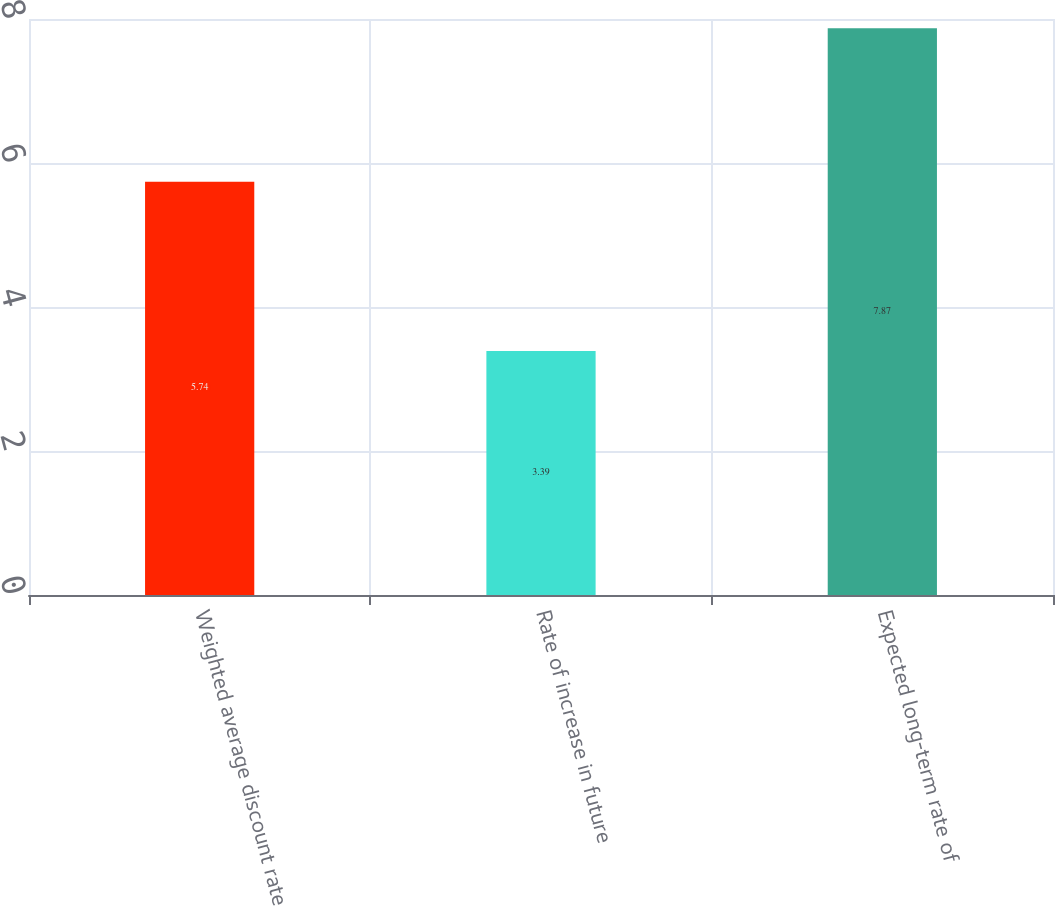<chart> <loc_0><loc_0><loc_500><loc_500><bar_chart><fcel>Weighted average discount rate<fcel>Rate of increase in future<fcel>Expected long-term rate of<nl><fcel>5.74<fcel>3.39<fcel>7.87<nl></chart> 